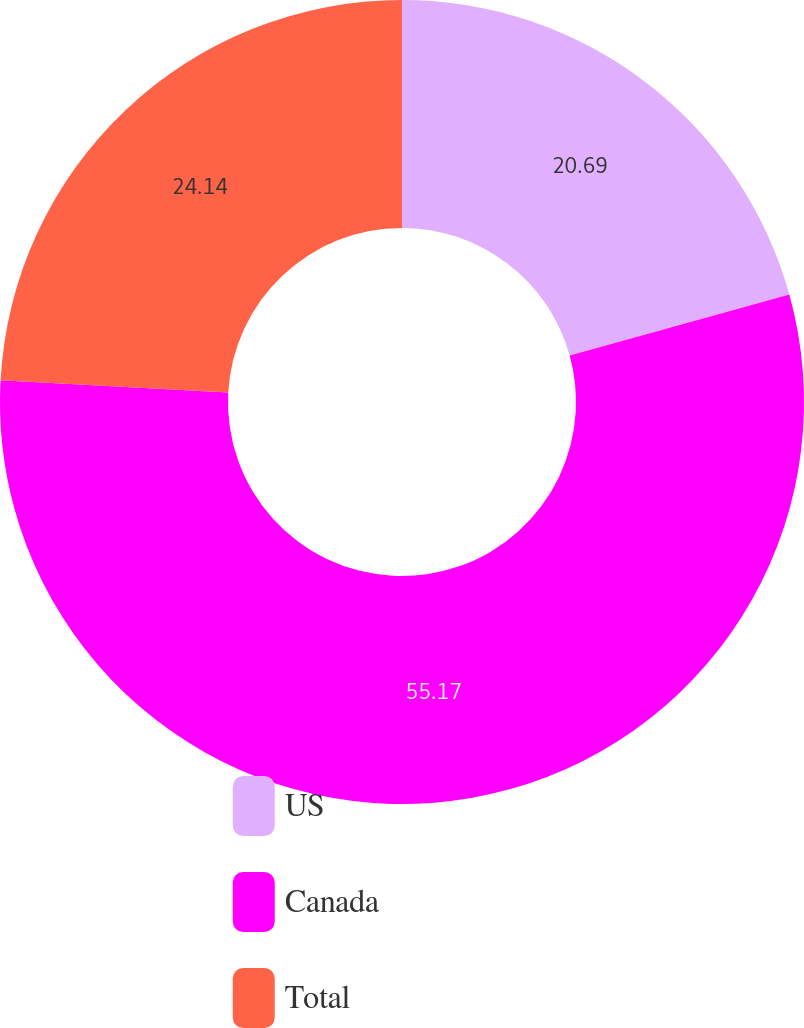<chart> <loc_0><loc_0><loc_500><loc_500><pie_chart><fcel>US<fcel>Canada<fcel>Total<nl><fcel>20.69%<fcel>55.17%<fcel>24.14%<nl></chart> 